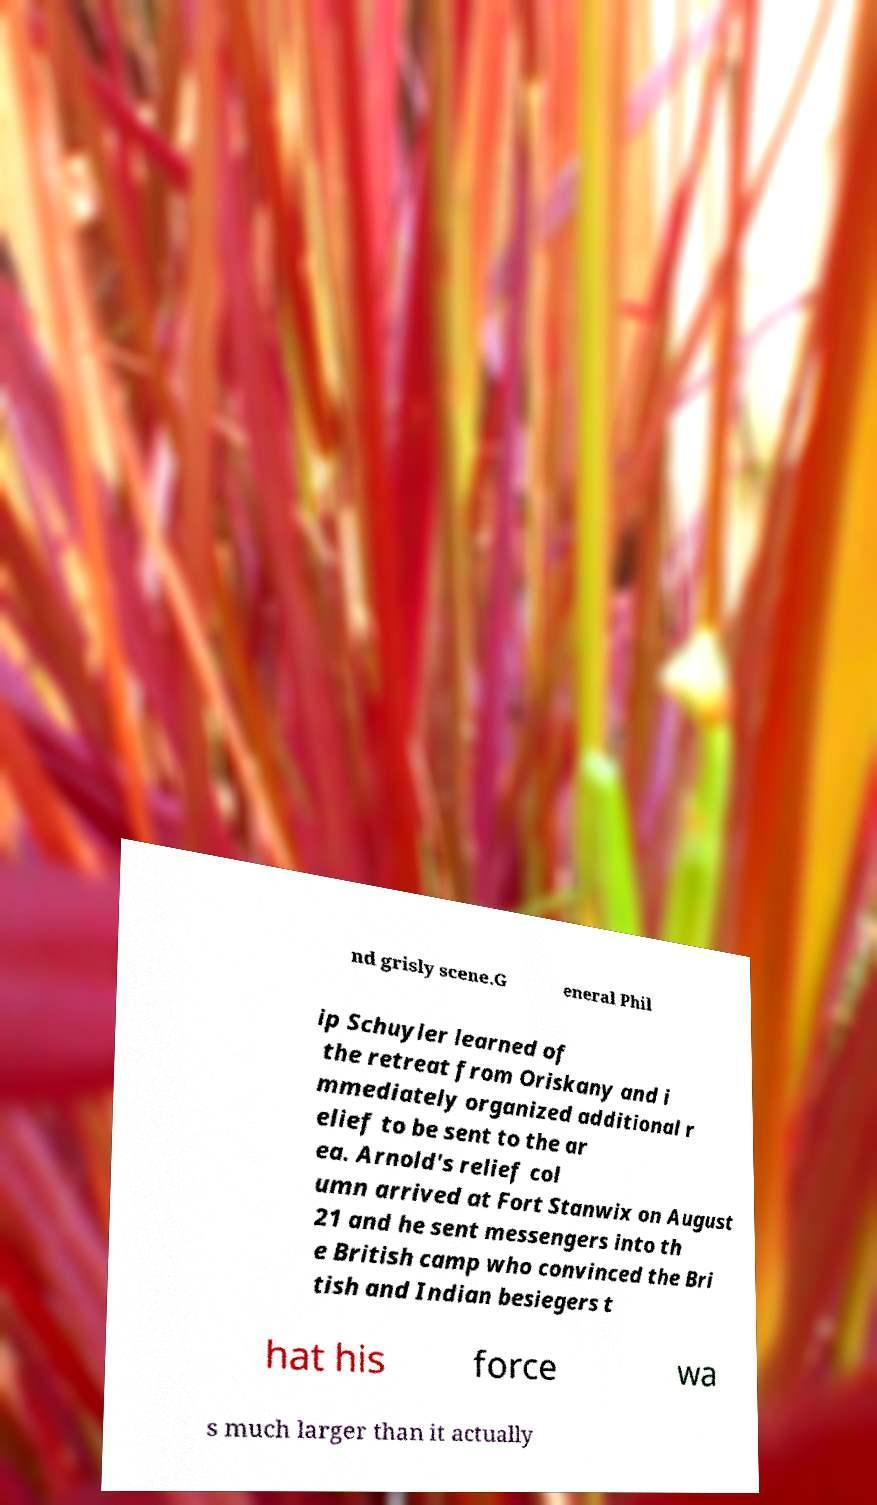There's text embedded in this image that I need extracted. Can you transcribe it verbatim? nd grisly scene.G eneral Phil ip Schuyler learned of the retreat from Oriskany and i mmediately organized additional r elief to be sent to the ar ea. Arnold's relief col umn arrived at Fort Stanwix on August 21 and he sent messengers into th e British camp who convinced the Bri tish and Indian besiegers t hat his force wa s much larger than it actually 